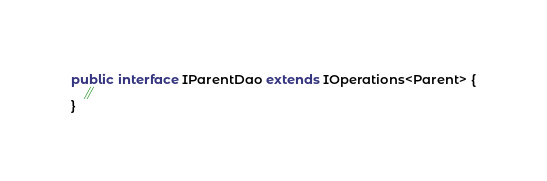Convert code to text. <code><loc_0><loc_0><loc_500><loc_500><_Java_>
public interface IParentDao extends IOperations<Parent> {
    //
}
</code> 